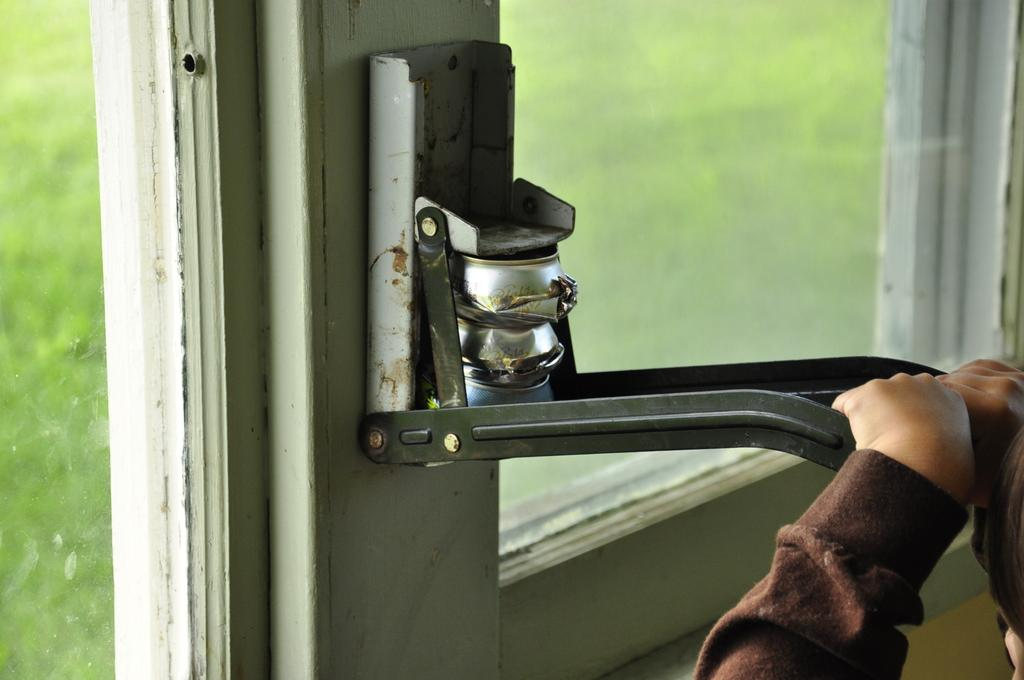What is the main object in the foreground of the image? There is an object present in the foreground of the image. Who is interacting with the object in the image? A person is holding the handle of the object. What can be seen through the window in the image? Grass is visible through the window. How does the scarecrow use the glue to gain approval in the image? There is no scarecrow or glue present in the image, and therefore no such activity can be observed. 